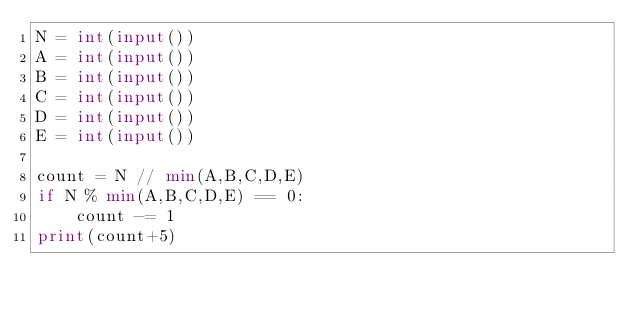Convert code to text. <code><loc_0><loc_0><loc_500><loc_500><_Python_>N = int(input())
A = int(input())
B = int(input())
C = int(input())
D = int(input())
E = int(input())

count = N // min(A,B,C,D,E)
if N % min(A,B,C,D,E) == 0:
    count -= 1
print(count+5)</code> 